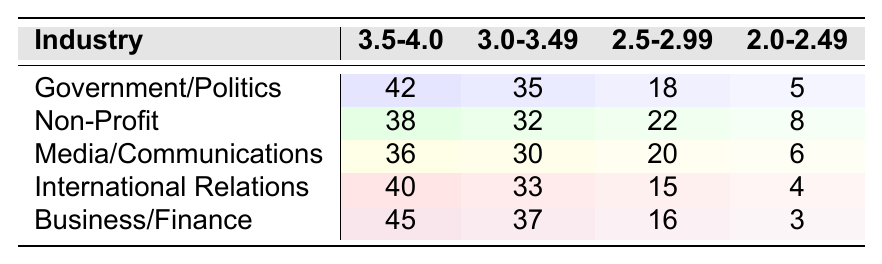What is the highest number of internship placements in the GPA range of 3.5-4.0? The highest number in the 3.5-4.0 range is found in the Business/Finance industry, which has 45 placements.
Answer: 45 Which industry has the lowest number of placements in the GPA range of 2.0-2.49? In the 2.0-2.49 range, the lowest number of placements is 3, which is in the Business/Finance industry.
Answer: Business/Finance What is the total number of internship placements for the Government/Politics industry across all GPA ranges? To calculate the total placements for Government/Politics, we add the placements: 42 + 35 + 18 + 5 = 100.
Answer: 100 Which GPA range has the highest total placements when considering all industries combined? By summing the placements in each GPA range: 3.5-4.0 has 42 + 38 + 36 + 40 + 45 = 201, 3.0-3.49 has 35 + 32 + 30 + 33 + 37 = 167, 2.5-2.99 has 18 + 22 + 20 + 15 + 16 = 91, and 2.0-2.49 has 5 + 8 + 6 + 4 + 3 = 26. Hence, 3.5-4.0 has the highest total placements at 201.
Answer: 3.5-4.0 Is there an industry with the same number of placements in the GPA range of 3.0-3.49? Yes, both Media/Communications and International Relations have the same number of placements in the 3.0-3.49 range, with 30 and 33 placements, respectively.
Answer: Yes What is the average number of internship placements in the GPA range of 2.5-2.99 for all industries? We calculate the average by adding placements: 18 + 22 + 20 + 15 + 16 = 91, then divide by 5 industries, resulting in an average of 91/5 = 18.2.
Answer: 18.2 Which industry has a higher number of placements in the 3.0-3.49 range: Non-Profit or International Relations? Non-Profit has 32 placements, while International Relations has 33. Since 33 is greater than 32, International Relations has a higher number of placements.
Answer: International Relations What is the difference in internship placements between the highest and lowest placements in the GPA range of 2.5-2.99? The highest placement in this range is 22 (Non-Profit) and the lowest is 15 (International Relations). The difference is 22 - 15 = 7.
Answer: 7 In which GPA range does Media/Communications have the same number of placements as Non-Profit? Comparing Media/Communications with Non-Profit, we see that in the 3.0-3.49 range, Media/Communications has 30 placements, while Non-Profit has 32. They do not match in any range.
Answer: No matching range What is the total number of placements in the 2.0-2.49 range across all industries? Adding the placements in the 2.0-2.49 range results in a total: 5 + 8 + 6 + 4 + 3 = 26.
Answer: 26 